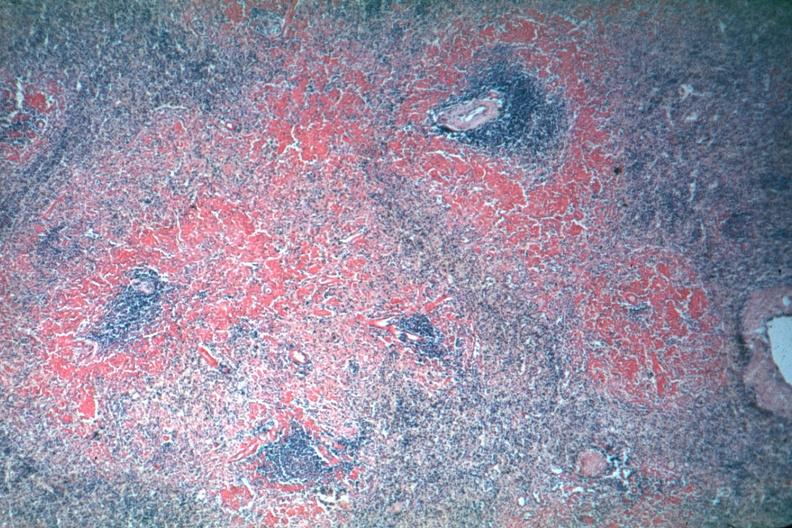what are red perifollicular amyloid deposits is not the best?
Answer the question using a single word or phrase. Well shown though exposure 